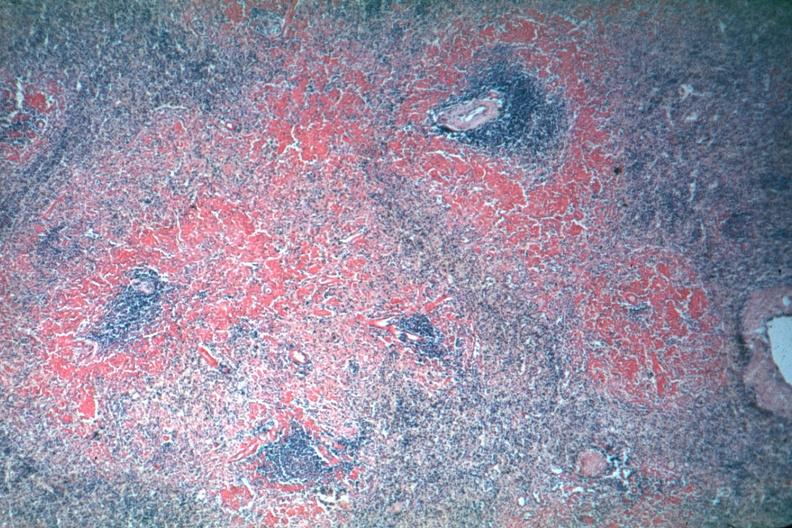what are red perifollicular amyloid deposits is not the best?
Answer the question using a single word or phrase. Well shown though exposure 